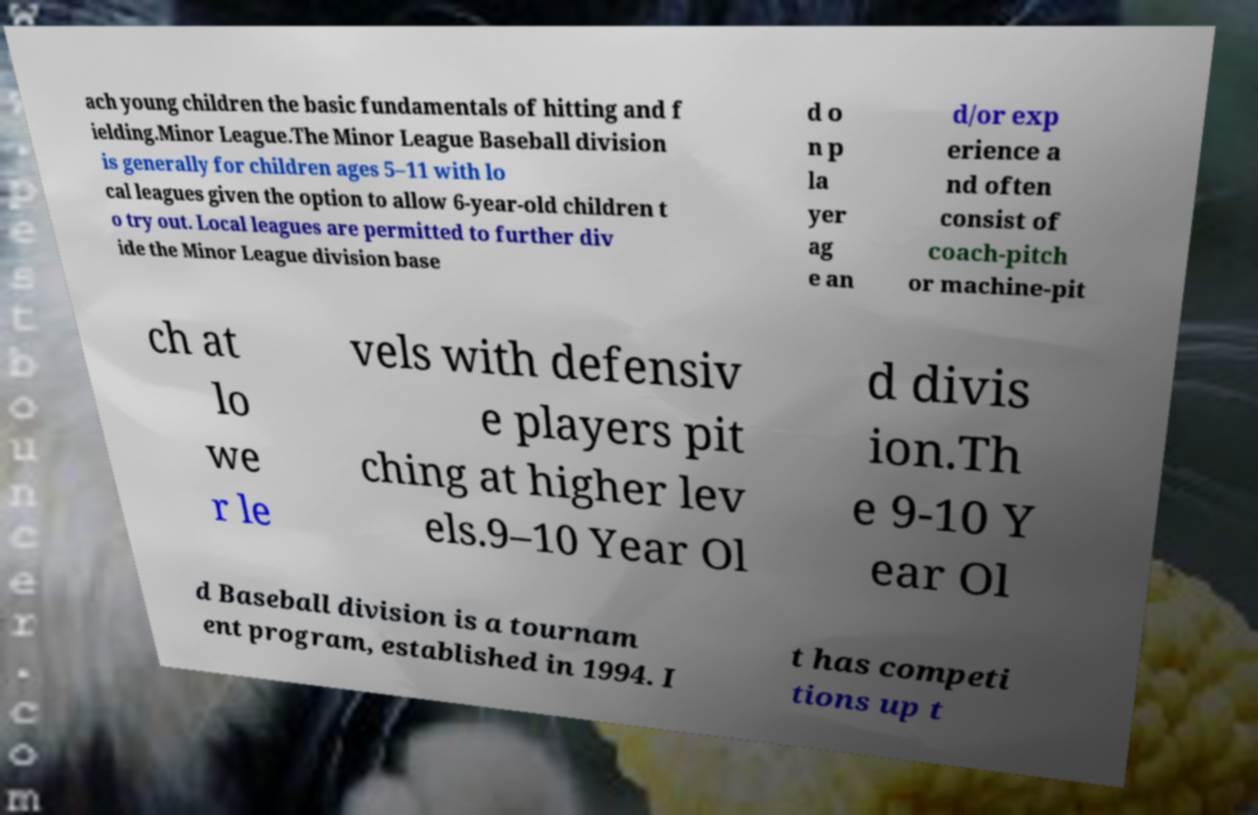There's text embedded in this image that I need extracted. Can you transcribe it verbatim? ach young children the basic fundamentals of hitting and f ielding.Minor League.The Minor League Baseball division is generally for children ages 5–11 with lo cal leagues given the option to allow 6-year-old children t o try out. Local leagues are permitted to further div ide the Minor League division base d o n p la yer ag e an d/or exp erience a nd often consist of coach-pitch or machine-pit ch at lo we r le vels with defensiv e players pit ching at higher lev els.9–10 Year Ol d divis ion.Th e 9-10 Y ear Ol d Baseball division is a tournam ent program, established in 1994. I t has competi tions up t 